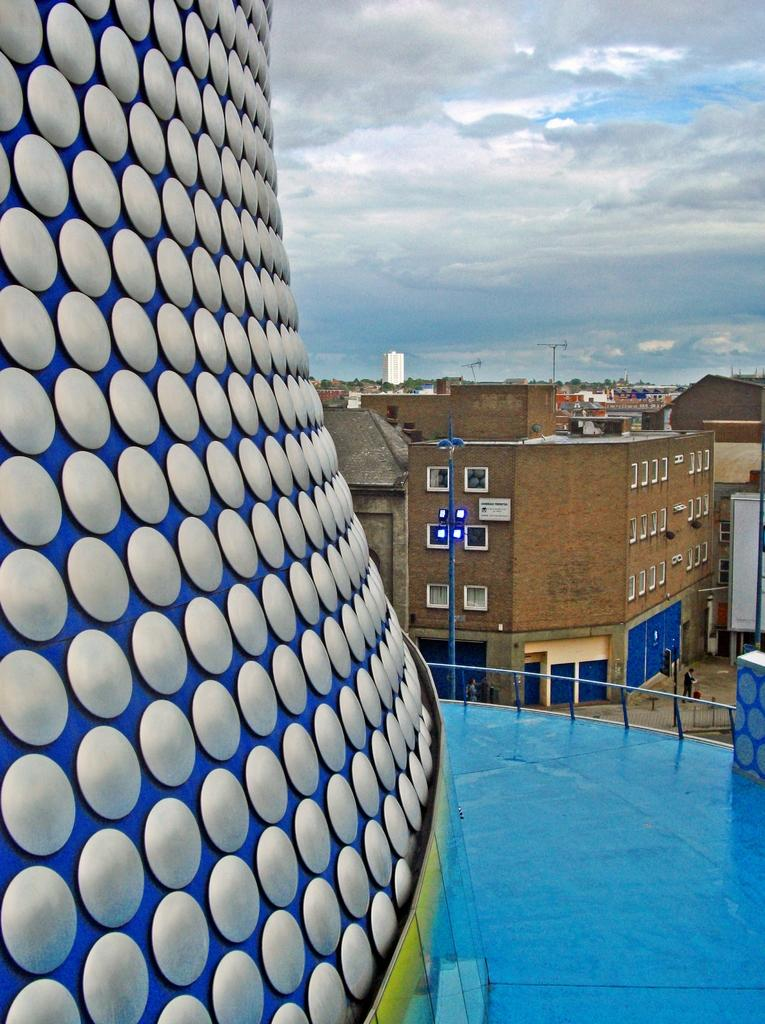What can be seen on the left side of the image? There is a design on the wall on the left side of the image. What is present in the middle of the image? There is a path in the image. What is located on the right side of the image? There is a fence in the image. What can be seen in the background of the image? There are buildings, windows, people, trees, and clouds visible in the background of the image. What form does the weather take in the image? The image does not depict any specific form of weather; it only shows clouds in the sky. What act are the people on the road in the background of the image performing? The image does not show any specific act being performed by the people on the road; they are simply walking or standing. 